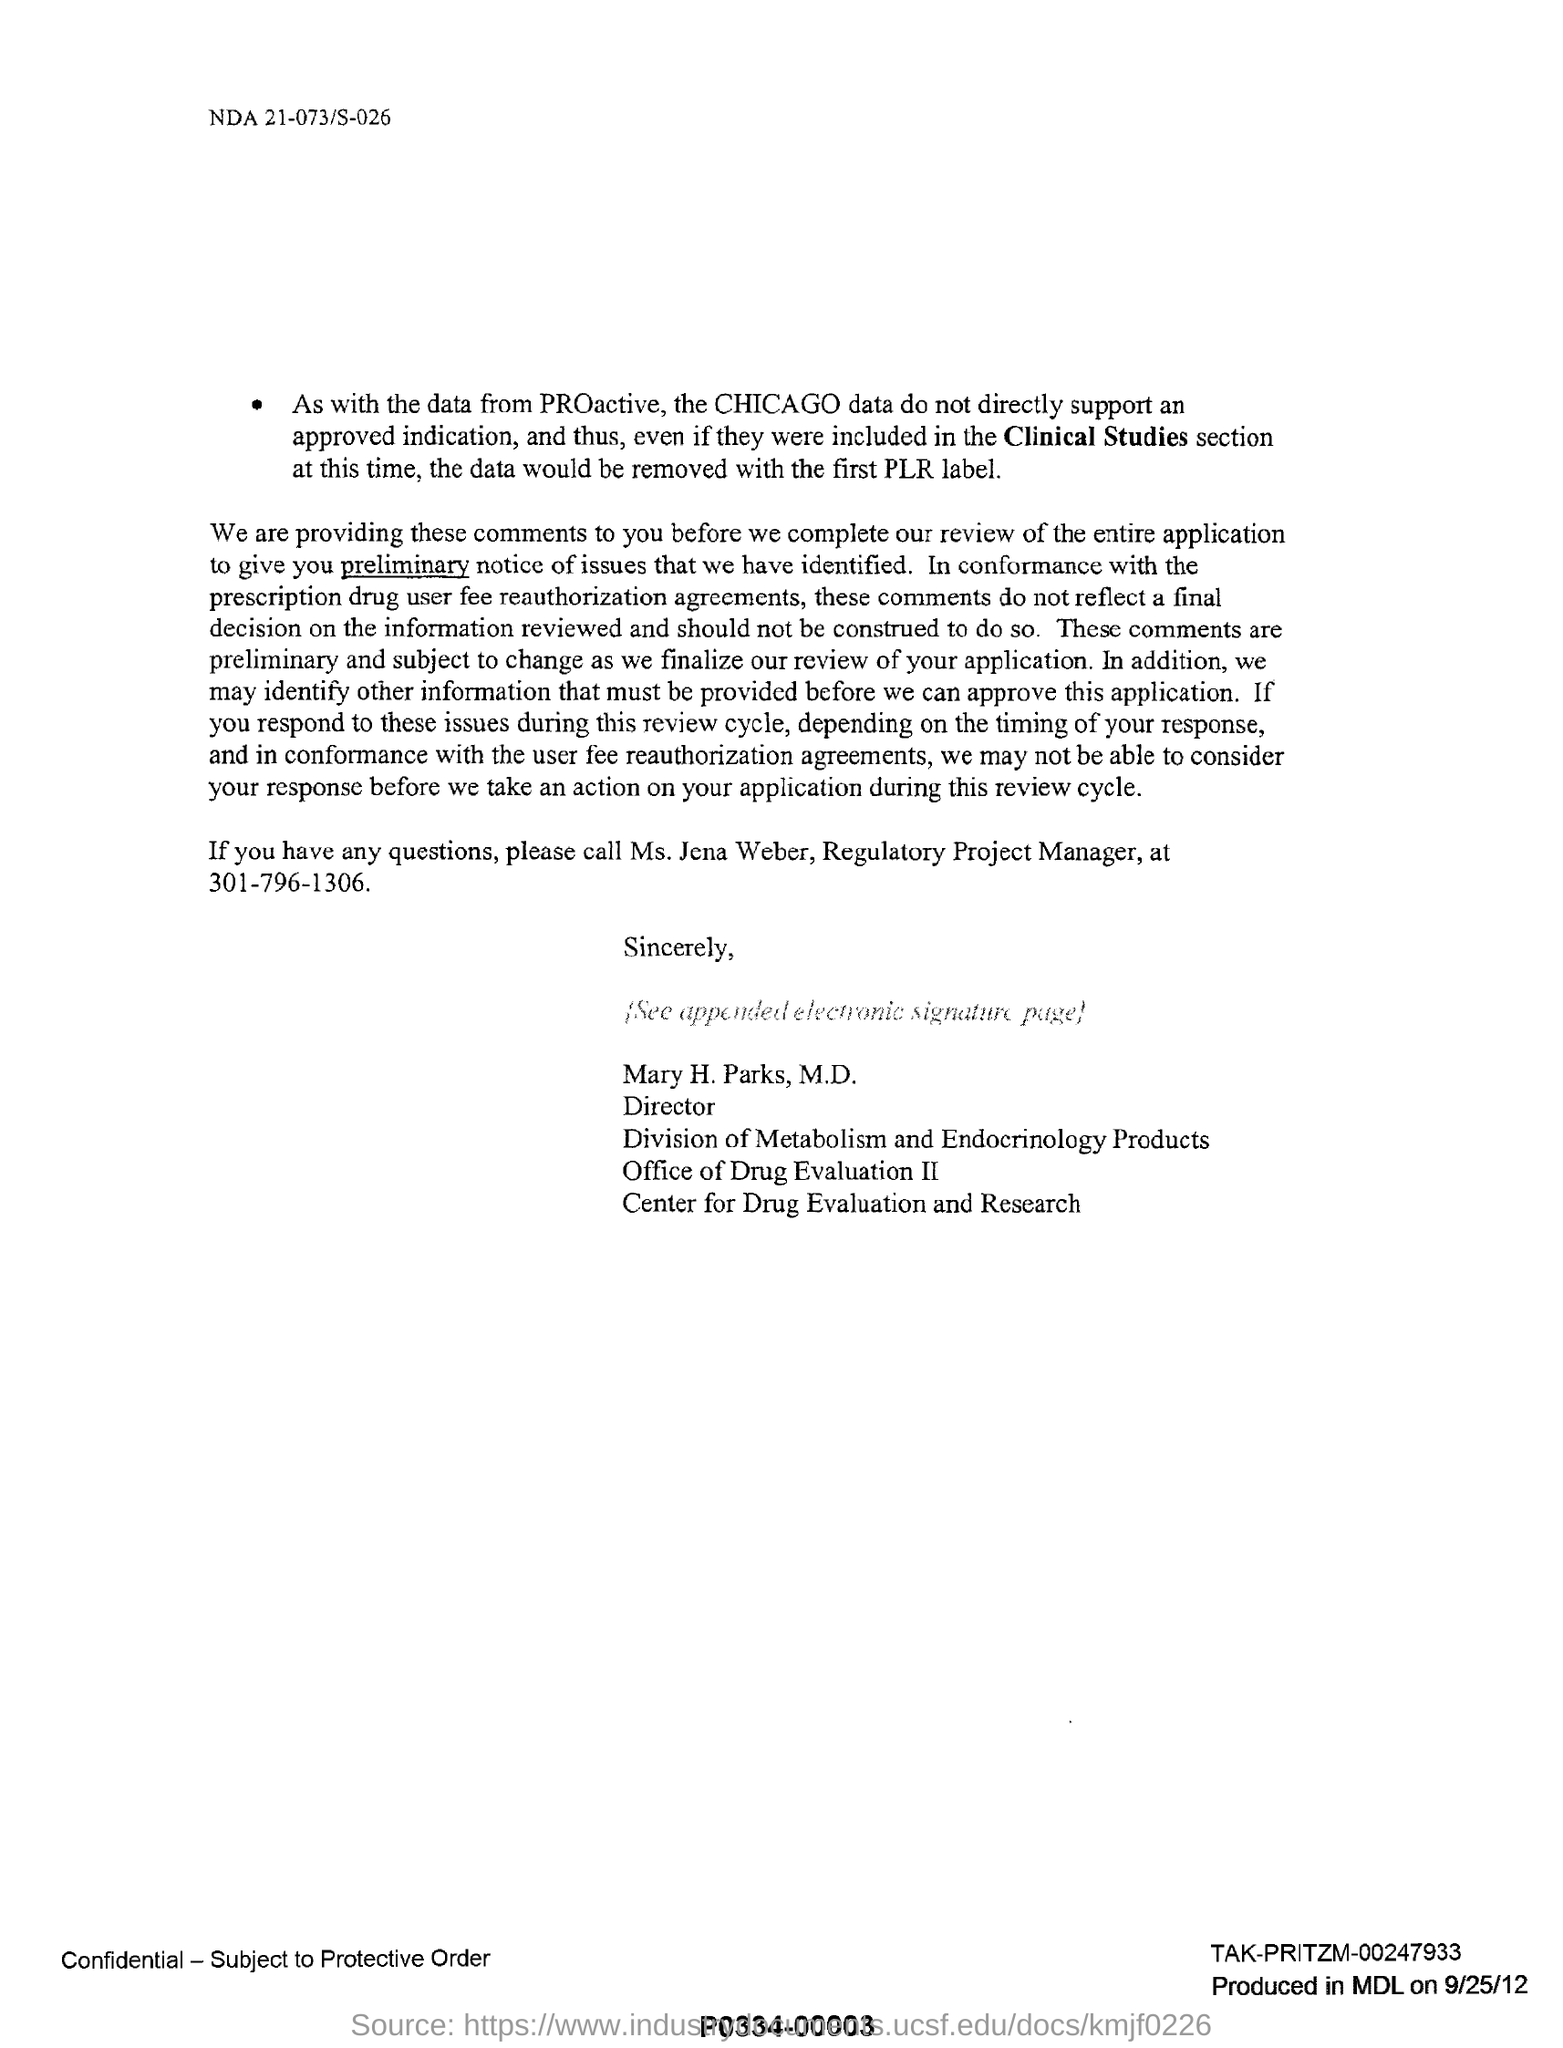Who has signed this document?
Your answer should be very brief. Mary H. Parks, M.D. What is the designation of Mary H.Parks, M.D.?
Your answer should be compact. Director. What is the designation of Ms. Jena Weber?
Your answer should be very brief. Regulatory Project Manager. What is the contact no of Ms. Jena Weber?
Your answer should be compact. 301-796-1306. 